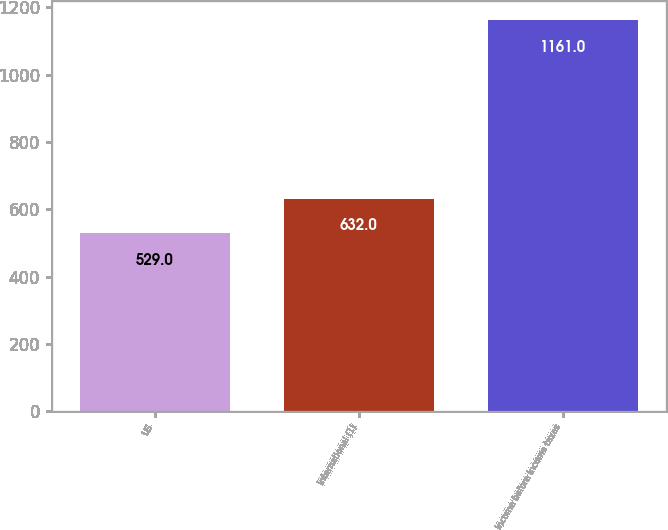<chart> <loc_0><loc_0><loc_500><loc_500><bar_chart><fcel>US<fcel>International (1)<fcel>Income before income taxes<nl><fcel>529<fcel>632<fcel>1161<nl></chart> 